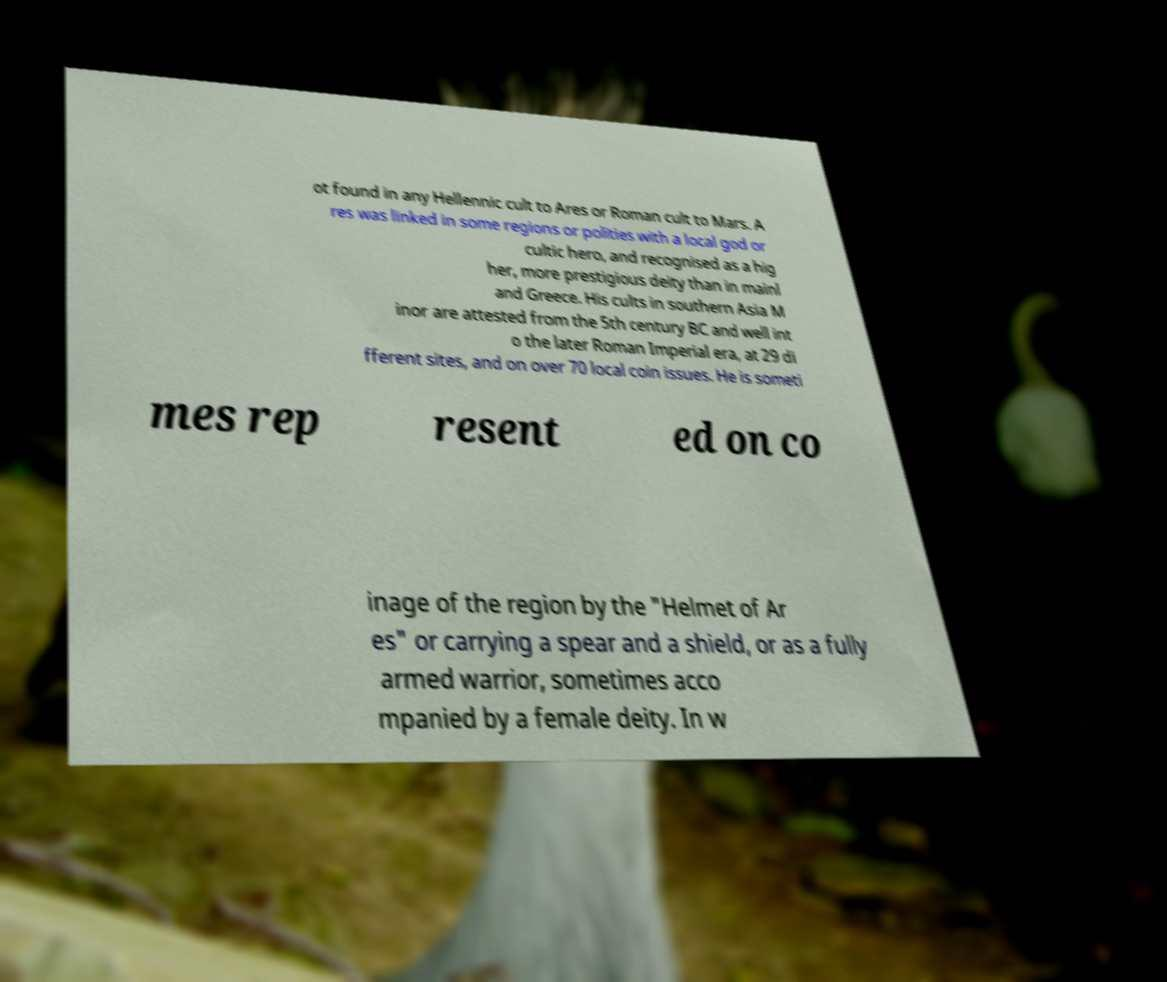What messages or text are displayed in this image? I need them in a readable, typed format. ot found in any Hellennic cult to Ares or Roman cult to Mars. A res was linked in some regions or polities with a local god or cultic hero, and recognised as a hig her, more prestigious deity than in mainl and Greece. His cults in southern Asia M inor are attested from the 5th century BC and well int o the later Roman Imperial era, at 29 di fferent sites, and on over 70 local coin issues. He is someti mes rep resent ed on co inage of the region by the "Helmet of Ar es" or carrying a spear and a shield, or as a fully armed warrior, sometimes acco mpanied by a female deity. In w 